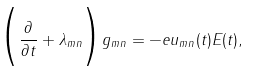<formula> <loc_0><loc_0><loc_500><loc_500>\Big { ( } \frac { \partial } { \partial t } + \lambda _ { m n } \Big { ) } g _ { m n } = - e u _ { m n } ( t ) E ( t ) ,</formula> 